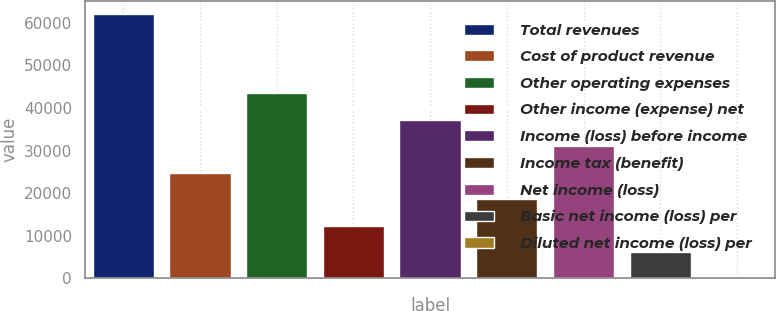Convert chart. <chart><loc_0><loc_0><loc_500><loc_500><bar_chart><fcel>Total revenues<fcel>Cost of product revenue<fcel>Other operating expenses<fcel>Other income (expense) net<fcel>Income (loss) before income<fcel>Income tax (benefit)<fcel>Net income (loss)<fcel>Basic net income (loss) per<fcel>Diluted net income (loss) per<nl><fcel>62005<fcel>24802.2<fcel>43403.6<fcel>12401.2<fcel>37203.1<fcel>18601.7<fcel>31002.7<fcel>6200.77<fcel>0.3<nl></chart> 